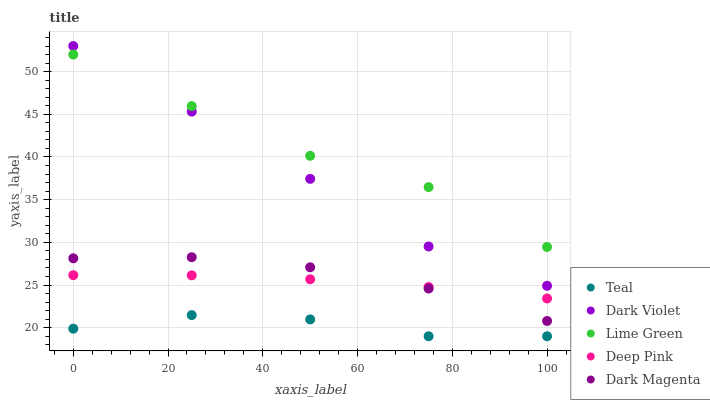Does Teal have the minimum area under the curve?
Answer yes or no. Yes. Does Lime Green have the maximum area under the curve?
Answer yes or no. Yes. Does Dark Violet have the minimum area under the curve?
Answer yes or no. No. Does Dark Violet have the maximum area under the curve?
Answer yes or no. No. Is Deep Pink the smoothest?
Answer yes or no. Yes. Is Lime Green the roughest?
Answer yes or no. Yes. Is Dark Violet the smoothest?
Answer yes or no. No. Is Dark Violet the roughest?
Answer yes or no. No. Does Teal have the lowest value?
Answer yes or no. Yes. Does Dark Violet have the lowest value?
Answer yes or no. No. Does Dark Violet have the highest value?
Answer yes or no. Yes. Does Lime Green have the highest value?
Answer yes or no. No. Is Dark Magenta less than Lime Green?
Answer yes or no. Yes. Is Lime Green greater than Dark Magenta?
Answer yes or no. Yes. Does Dark Magenta intersect Deep Pink?
Answer yes or no. Yes. Is Dark Magenta less than Deep Pink?
Answer yes or no. No. Is Dark Magenta greater than Deep Pink?
Answer yes or no. No. Does Dark Magenta intersect Lime Green?
Answer yes or no. No. 